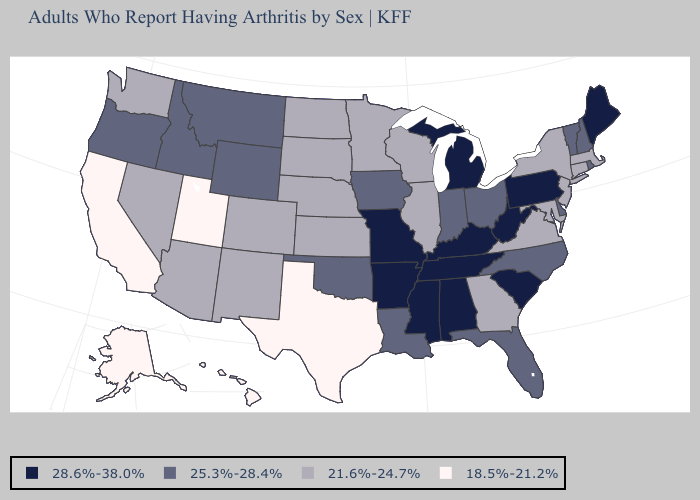What is the highest value in states that border Connecticut?
Quick response, please. 25.3%-28.4%. What is the lowest value in the USA?
Answer briefly. 18.5%-21.2%. Which states have the lowest value in the USA?
Give a very brief answer. Alaska, California, Hawaii, Texas, Utah. What is the highest value in the USA?
Be succinct. 28.6%-38.0%. Among the states that border Massachusetts , which have the lowest value?
Concise answer only. Connecticut, New York. What is the highest value in states that border Nebraska?
Short answer required. 28.6%-38.0%. What is the value of Missouri?
Keep it brief. 28.6%-38.0%. Name the states that have a value in the range 25.3%-28.4%?
Quick response, please. Delaware, Florida, Idaho, Indiana, Iowa, Louisiana, Montana, New Hampshire, North Carolina, Ohio, Oklahoma, Oregon, Rhode Island, Vermont, Wyoming. What is the value of Rhode Island?
Concise answer only. 25.3%-28.4%. Which states hav the highest value in the MidWest?
Quick response, please. Michigan, Missouri. Which states hav the highest value in the MidWest?
Concise answer only. Michigan, Missouri. Does Pennsylvania have the highest value in the USA?
Concise answer only. Yes. What is the highest value in the West ?
Short answer required. 25.3%-28.4%. What is the value of North Carolina?
Give a very brief answer. 25.3%-28.4%. 